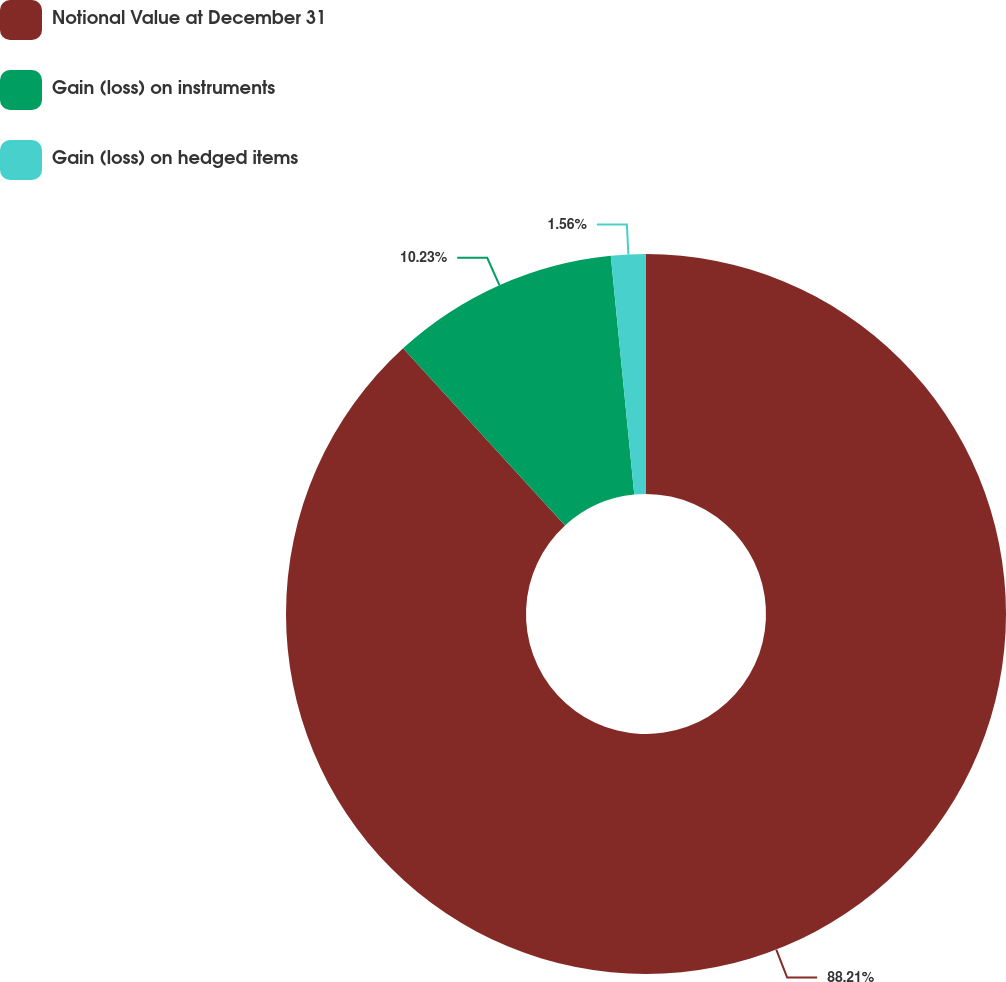Convert chart. <chart><loc_0><loc_0><loc_500><loc_500><pie_chart><fcel>Notional Value at December 31<fcel>Gain (loss) on instruments<fcel>Gain (loss) on hedged items<nl><fcel>88.22%<fcel>10.23%<fcel>1.56%<nl></chart> 